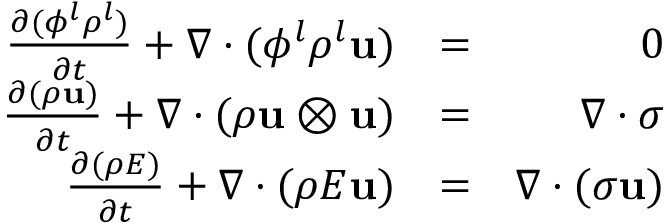Convert formula to latex. <formula><loc_0><loc_0><loc_500><loc_500>\begin{array} { r l r } { \frac { \partial ( \phi ^ { l } \rho ^ { l } ) } { \partial t } + \nabla \cdot ( \phi ^ { l } \rho ^ { l } u ) } & { = } & { 0 } \\ { \frac { \partial ( \rho u ) } { \partial t } + \nabla \cdot ( \rho u \otimes u ) } & { = } & { \nabla \cdot \boldsymbol \sigma } \\ { \frac { \partial ( \rho E ) } { \partial t } + \nabla \cdot ( \rho E u ) } & { = } & { \nabla \cdot ( \boldsymbol \sigma u ) } \end{array}</formula> 